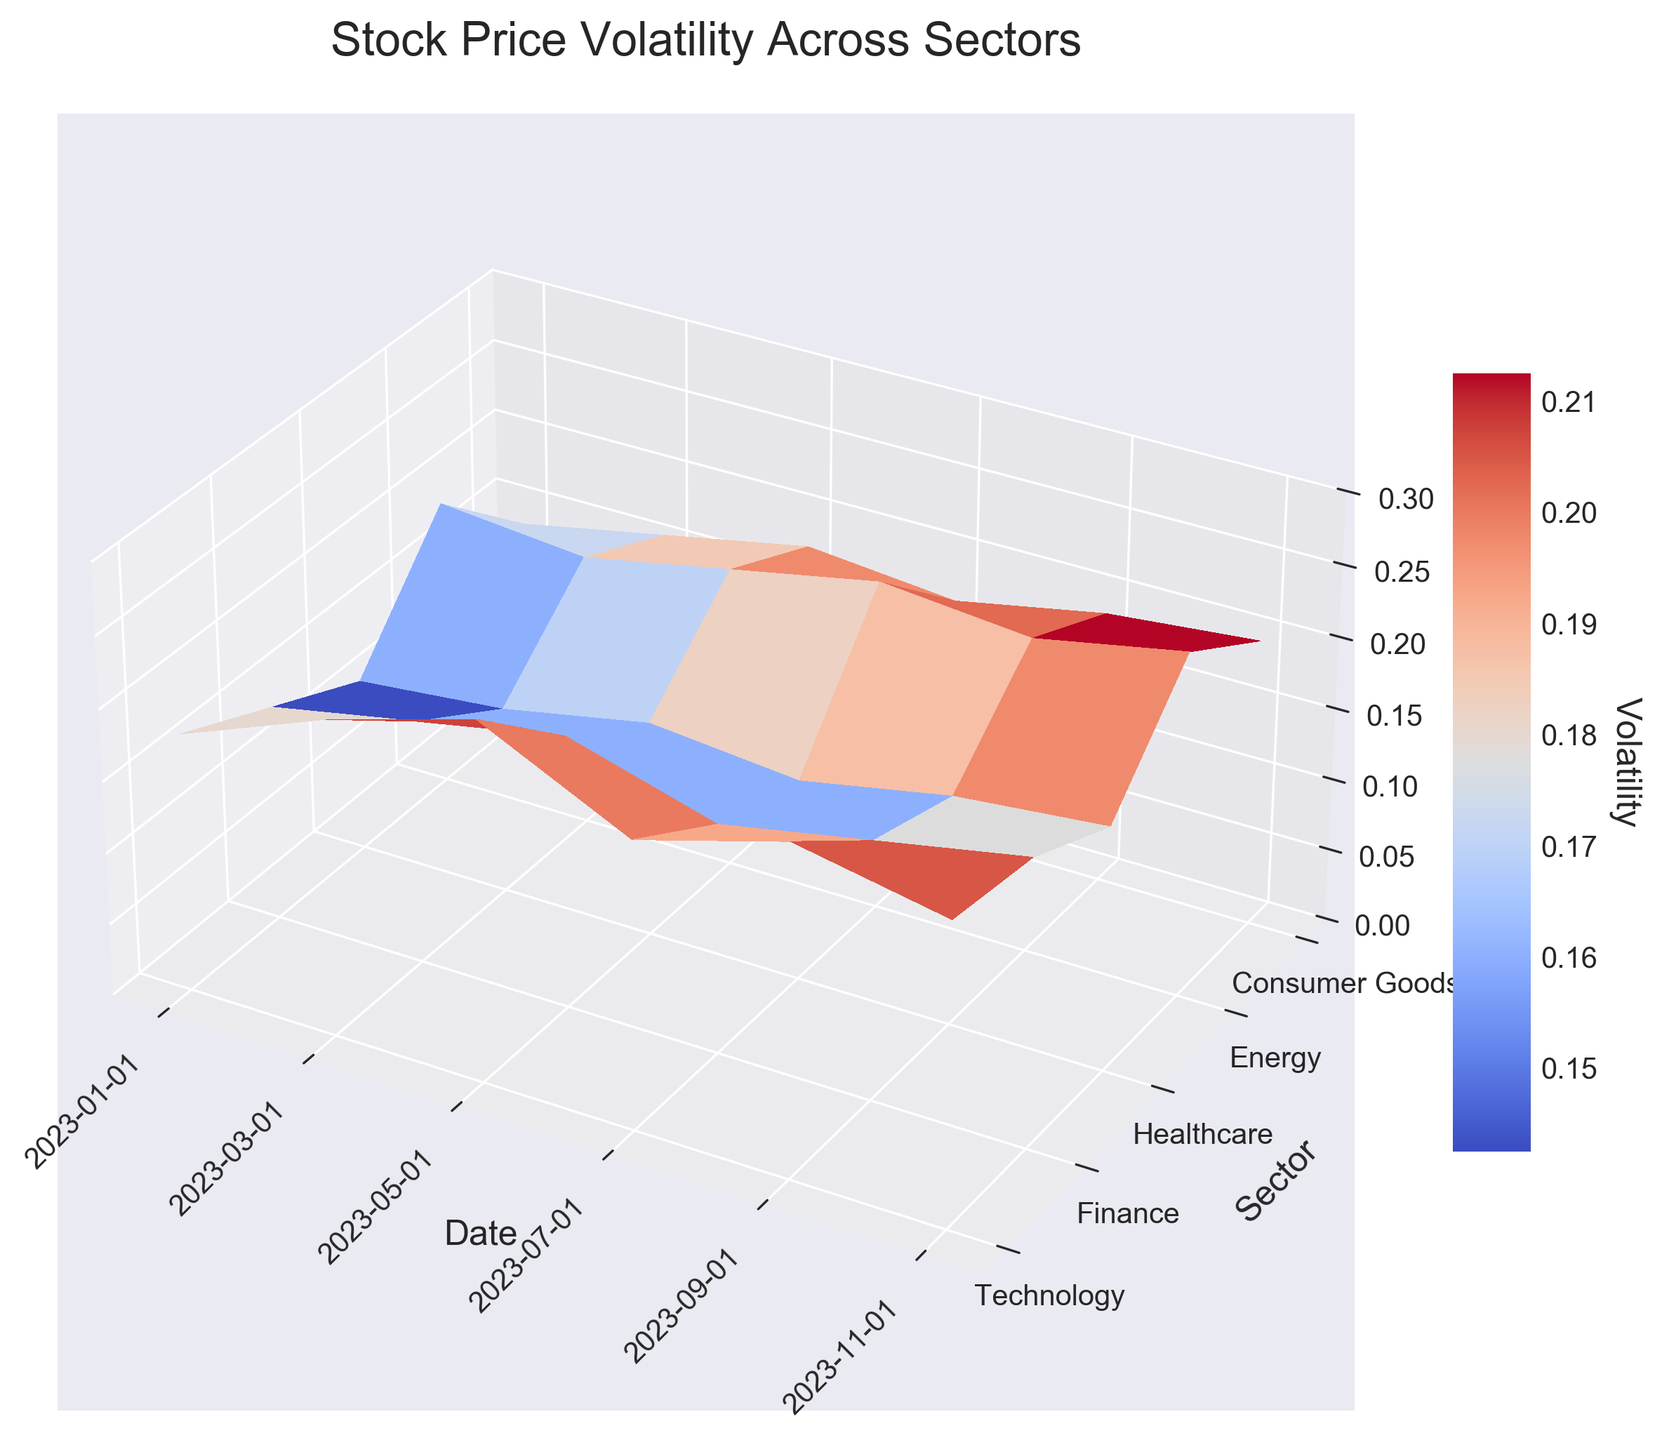What's the title of the figure? The title of the figure is a text element usually located at the top of a plot and gives a summary of what the figure represents. In this figure, it's labeled at the top of the plot.
Answer: Stock Price Volatility Across Sectors What do the axes represent? Each axis in the figure is labeled to indicate what is being measured. The x-axis represents the 'Date', the y-axis represents the 'Sector', and the z-axis represents 'Volatility'.
Answer: Date, Sector, Volatility Which sector had the highest volatility on 2023-05-01? To answer this, look at the 3D plot and find the point corresponding to 2023-05-01 on the x-axis. Then, observe which sector on the y-axis has the highest z-coordinate (volatility) value on this date.
Answer: Technology What is the overall range of volatility values on the z-axis? The range of the z-axis can be seen by looking at the limits set on the z-axis in the figure. The lower limit is 0 and the upper limit is 0.3.
Answer: 0 to 0.3 On which date did the Energy sector experience its highest volatility? Locate all the points corresponding to Energy on the y-axis and find their z-values over time. The highest z-value will indicate the date of the highest volatility.
Answer: 2023-11-01 Which sector showed the least variability in volatility over time? To find the sector with the least variability, compare the heights of the plots on the z-axis for each sector across all dates. The sector with the smallest fluctuation in height represents the least variability.
Answer: Healthcare How did the volatility of the Consumer Goods sector change from 2023-01-01 to 2023-11-01? Locate the points corresponding to Consumer Goods on the y-axis and track their z-values (volatility) from the start to the end date. Note how it increased or decreased over time.
Answer: Increased Which two sectors had their highest volatility values in the same month and what month was it? Identify the peak volatility value for each sector and note the corresponding dates. Two sectors with peaks in the same month can be spotted.
Answer: Energy and Consumer Goods, 2023-11-01 How does the volatility of the Finance sector on 2023-07-01 compare to its volatility on 2023-11-01? Examine the z-values of the Finance sector on the corresponding dates. Then compare both values to see which is higher.
Answer: Lower on 2023-07-01 than on 2023-11-01 What pattern can you observe about the Technology sector's volatility over the year? Observing the heights of the plot for the Technology sector over time, note the general trend such as increasing, decreasing, or fluctuating pattern.
Answer: It fluctuates but shows an overall increase towards the middle then decreases slightly by the end 